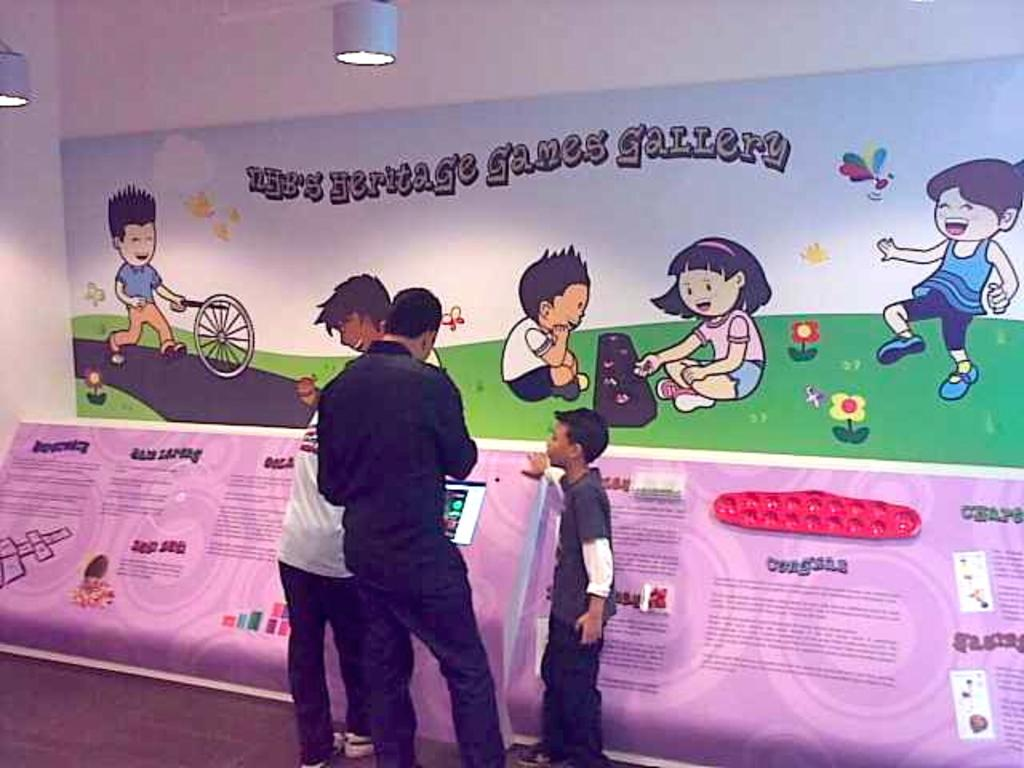What is the main subject in the middle of the image? There is a kid and two men in the middle of the image. What can be seen in the background of the image? There are hoardings and a painting in the background of the image. Can you describe the lighting in the image? There is a light visible at the top of the image. What type of skin condition can be seen on the kid in the image? There is no indication of any skin condition on the kid in the image. Can you tell me how deep the river is in the image? There is no river present in the image. 